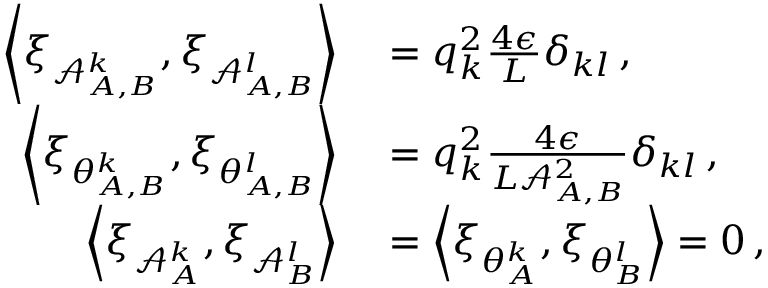<formula> <loc_0><loc_0><loc_500><loc_500>\begin{array} { r l } { \left \langle \xi _ { \mathcal { A } _ { A , B } ^ { k } } , \xi _ { \mathcal { A } _ { A , B } ^ { l } } \right \rangle } & = q _ { k } ^ { 2 } \frac { 4 \epsilon } { L } \delta _ { k l } \, , } \\ { \left \langle \xi _ { \theta _ { A , B } ^ { k } } , \xi _ { \theta _ { A , B } ^ { l } } \right \rangle } & = q _ { k } ^ { 2 } \frac { 4 \epsilon } { L \mathcal { A } _ { A , B } ^ { 2 } } \delta _ { k l } \, , } \\ { \left \langle \xi _ { \mathcal { A } _ { A } ^ { k } } , \xi _ { \mathcal { A } _ { B } ^ { l } } \right \rangle } & = \left \langle \xi _ { \theta _ { A } ^ { k } } , \xi _ { \theta _ { B } ^ { l } } \right \rangle = 0 \, , } \end{array}</formula> 